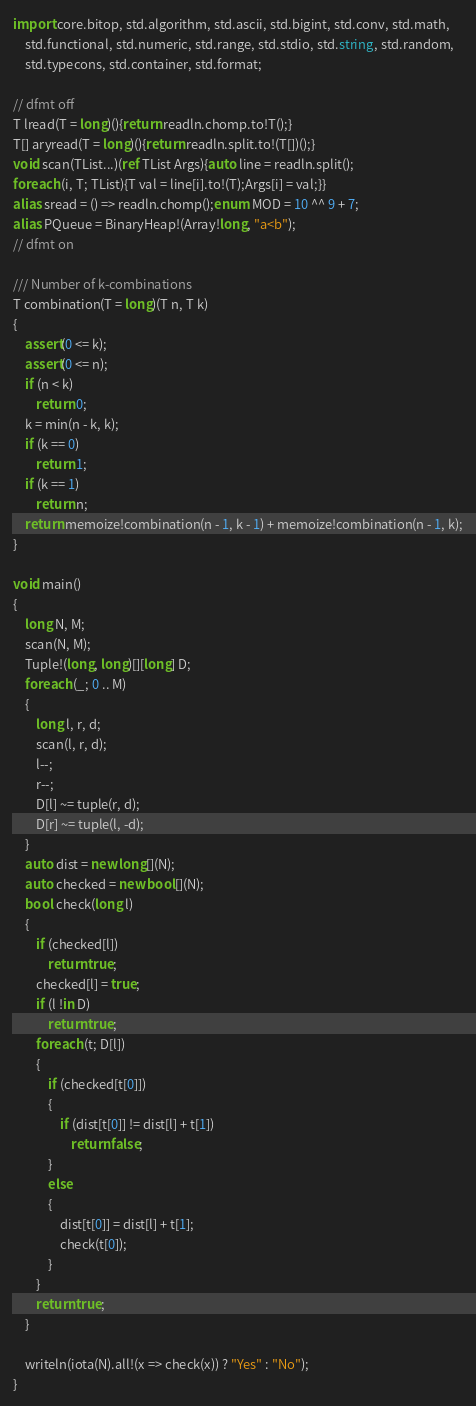<code> <loc_0><loc_0><loc_500><loc_500><_D_>import core.bitop, std.algorithm, std.ascii, std.bigint, std.conv, std.math,
    std.functional, std.numeric, std.range, std.stdio, std.string, std.random,
    std.typecons, std.container, std.format;

// dfmt off
T lread(T = long)(){return readln.chomp.to!T();}
T[] aryread(T = long)(){return readln.split.to!(T[])();}
void scan(TList...)(ref TList Args){auto line = readln.split();
foreach (i, T; TList){T val = line[i].to!(T);Args[i] = val;}}
alias sread = () => readln.chomp();enum MOD = 10 ^^ 9 + 7;
alias PQueue = BinaryHeap!(Array!long, "a<b");
// dfmt on

/// Number of k-combinations
T combination(T = long)(T n, T k)
{
    assert(0 <= k);
    assert(0 <= n);
    if (n < k)
        return 0;
    k = min(n - k, k);
    if (k == 0)
        return 1;
    if (k == 1)
        return n;
    return memoize!combination(n - 1, k - 1) + memoize!combination(n - 1, k);
}

void main()
{
    long N, M;
    scan(N, M);
    Tuple!(long, long)[][long] D;
    foreach (_; 0 .. M)
    {
        long l, r, d;
        scan(l, r, d);
        l--;
        r--;
        D[l] ~= tuple(r, d);
        D[r] ~= tuple(l, -d);
    }
    auto dist = new long[](N);
    auto checked = new bool[](N);
    bool check(long l)
    {
        if (checked[l])
            return true;
        checked[l] = true;
        if (l !in D)
            return true;
        foreach (t; D[l])
        {
            if (checked[t[0]])
            {
                if (dist[t[0]] != dist[l] + t[1])
                    return false;
            }
            else
            {
                dist[t[0]] = dist[l] + t[1];
                check(t[0]);
            }
        }
        return true;
    }

    writeln(iota(N).all!(x => check(x)) ? "Yes" : "No");
}
</code> 